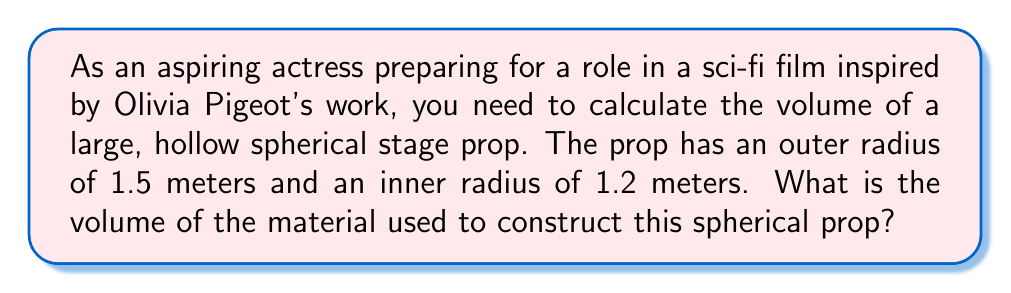Give your solution to this math problem. To solve this problem, we need to follow these steps:

1) The volume of a sphere is given by the formula:
   $$V = \frac{4}{3}\pi r^3$$

2) We need to calculate the volume of the outer sphere and subtract the volume of the inner sphere:
   $$V_{total} = V_{outer} - V_{inner}$$

3) For the outer sphere (radius 1.5 m):
   $$V_{outer} = \frac{4}{3}\pi (1.5)^3 = \frac{4}{3}\pi (3.375) = 4.5\pi$$

4) For the inner sphere (radius 1.2 m):
   $$V_{inner} = \frac{4}{3}\pi (1.2)^3 = \frac{4}{3}\pi (1.728) = 2.304\pi$$

5) Now we can subtract:
   $$V_{total} = V_{outer} - V_{inner} = 4.5\pi - 2.304\pi = 2.196\pi$$

6) To get the final answer in cubic meters:
   $$V_{total} = 2.196\pi \approx 6.90 \text{ m}^3$$

[asy]
import geometry;

size(200);
draw(circle((0,0),1.5), blue);
draw(circle((0,0),1.2), red+dashed);
label("1.5 m", (0.75,-0.75), blue);
label("1.2 m", (0.6,-0.6), red);
[/asy]
Answer: The volume of the material used to construct the spherical prop is approximately $6.90 \text{ m}^3$. 